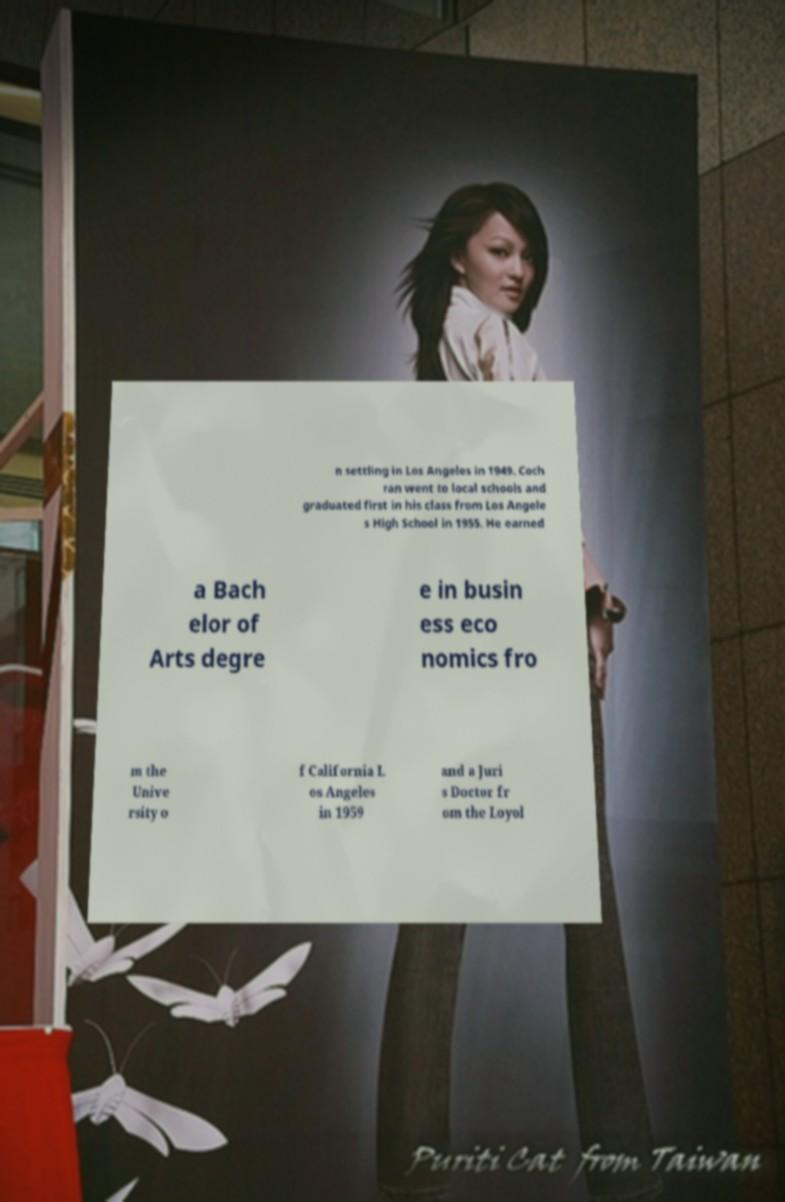Please read and relay the text visible in this image. What does it say? n settling in Los Angeles in 1949. Coch ran went to local schools and graduated first in his class from Los Angele s High School in 1955. He earned a Bach elor of Arts degre e in busin ess eco nomics fro m the Unive rsity o f California L os Angeles in 1959 and a Juri s Doctor fr om the Loyol 